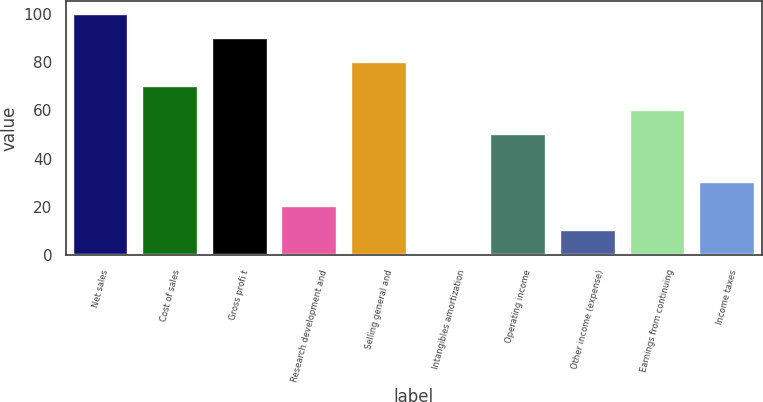<chart> <loc_0><loc_0><loc_500><loc_500><bar_chart><fcel>Net sales<fcel>Cost of sales<fcel>Gross profi t<fcel>Research development and<fcel>Selling general and<fcel>Intangibles amortization<fcel>Operating income<fcel>Other income (expense)<fcel>Earnings from continuing<fcel>Income taxes<nl><fcel>100<fcel>70.21<fcel>90.07<fcel>20.56<fcel>80.14<fcel>0.7<fcel>50.35<fcel>10.63<fcel>60.28<fcel>30.49<nl></chart> 